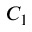<formula> <loc_0><loc_0><loc_500><loc_500>C _ { 1 }</formula> 